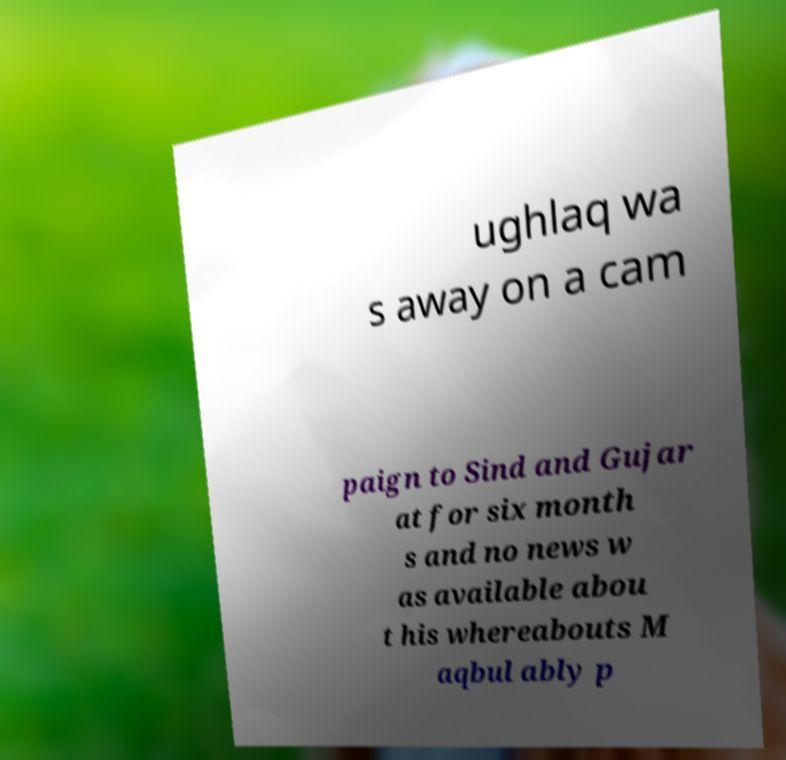Please identify and transcribe the text found in this image. ughlaq wa s away on a cam paign to Sind and Gujar at for six month s and no news w as available abou t his whereabouts M aqbul ably p 